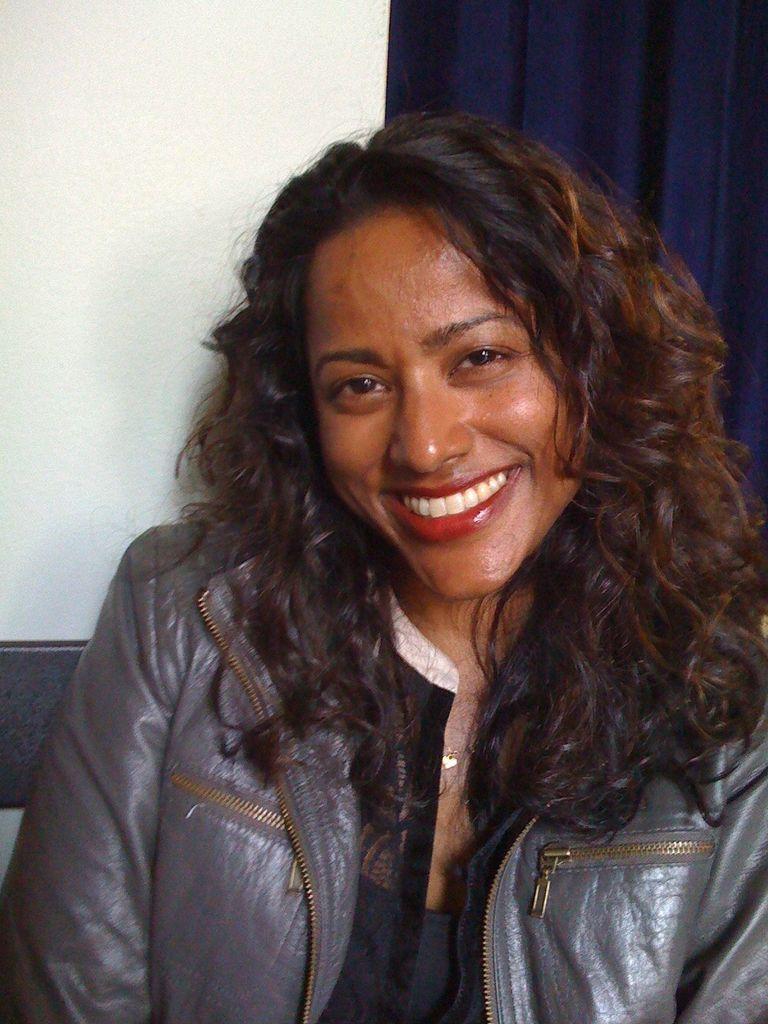Could you give a brief overview of what you see in this image? In this image there is a woman wearing a jacket, in the background there is a wall and blue curtain. 